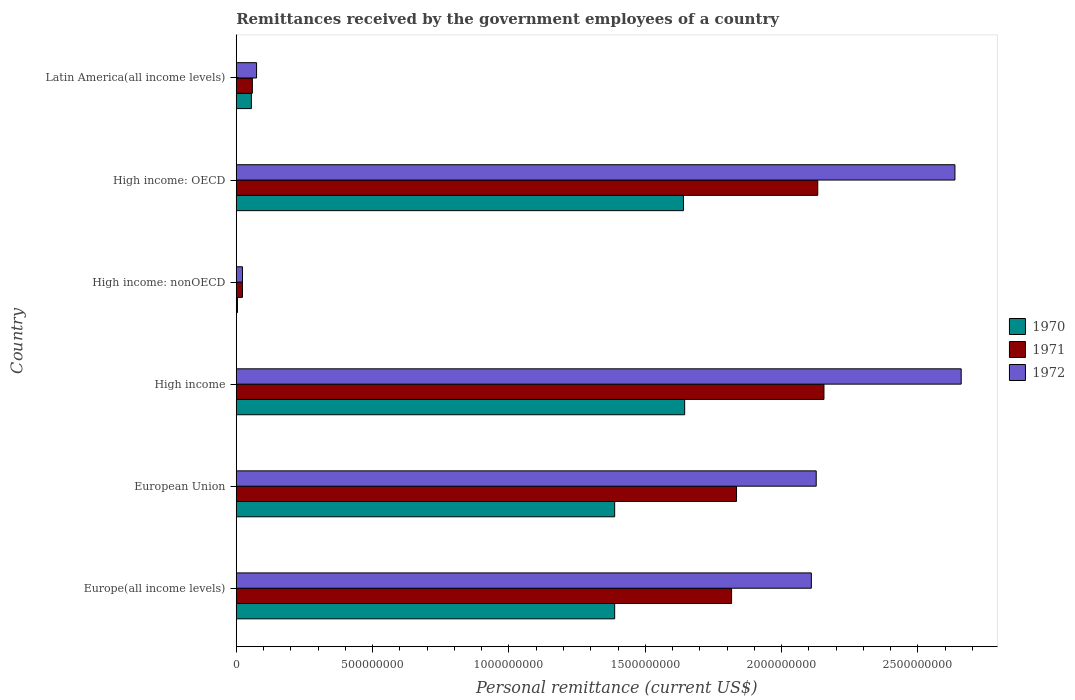How many different coloured bars are there?
Give a very brief answer. 3. Are the number of bars per tick equal to the number of legend labels?
Make the answer very short. Yes. Are the number of bars on each tick of the Y-axis equal?
Offer a very short reply. Yes. How many bars are there on the 5th tick from the top?
Ensure brevity in your answer.  3. What is the label of the 3rd group of bars from the top?
Offer a very short reply. High income: nonOECD. In how many cases, is the number of bars for a given country not equal to the number of legend labels?
Keep it short and to the point. 0. What is the remittances received by the government employees in 1970 in Europe(all income levels)?
Your response must be concise. 1.39e+09. Across all countries, what is the maximum remittances received by the government employees in 1972?
Your answer should be very brief. 2.66e+09. Across all countries, what is the minimum remittances received by the government employees in 1970?
Your answer should be compact. 4.40e+06. In which country was the remittances received by the government employees in 1970 maximum?
Your response must be concise. High income. In which country was the remittances received by the government employees in 1971 minimum?
Offer a very short reply. High income: nonOECD. What is the total remittances received by the government employees in 1970 in the graph?
Keep it short and to the point. 6.12e+09. What is the difference between the remittances received by the government employees in 1971 in European Union and that in High income: OECD?
Make the answer very short. -2.98e+08. What is the difference between the remittances received by the government employees in 1971 in High income and the remittances received by the government employees in 1972 in Latin America(all income levels)?
Ensure brevity in your answer.  2.08e+09. What is the average remittances received by the government employees in 1970 per country?
Ensure brevity in your answer.  1.02e+09. What is the difference between the remittances received by the government employees in 1971 and remittances received by the government employees in 1970 in Europe(all income levels)?
Your answer should be very brief. 4.29e+08. What is the ratio of the remittances received by the government employees in 1970 in Europe(all income levels) to that in High income: nonOECD?
Make the answer very short. 315.41. Is the remittances received by the government employees in 1972 in High income less than that in Latin America(all income levels)?
Offer a very short reply. No. What is the difference between the highest and the second highest remittances received by the government employees in 1972?
Provide a succinct answer. 2.29e+07. What is the difference between the highest and the lowest remittances received by the government employees in 1970?
Your response must be concise. 1.64e+09. What does the 3rd bar from the top in Latin America(all income levels) represents?
Provide a succinct answer. 1970. What is the difference between two consecutive major ticks on the X-axis?
Provide a short and direct response. 5.00e+08. Are the values on the major ticks of X-axis written in scientific E-notation?
Your answer should be very brief. No. Does the graph contain grids?
Provide a succinct answer. No. How are the legend labels stacked?
Ensure brevity in your answer.  Vertical. What is the title of the graph?
Offer a terse response. Remittances received by the government employees of a country. What is the label or title of the X-axis?
Give a very brief answer. Personal remittance (current US$). What is the label or title of the Y-axis?
Make the answer very short. Country. What is the Personal remittance (current US$) of 1970 in Europe(all income levels)?
Provide a succinct answer. 1.39e+09. What is the Personal remittance (current US$) of 1971 in Europe(all income levels)?
Your answer should be very brief. 1.82e+09. What is the Personal remittance (current US$) of 1972 in Europe(all income levels)?
Offer a terse response. 2.11e+09. What is the Personal remittance (current US$) of 1970 in European Union?
Offer a terse response. 1.39e+09. What is the Personal remittance (current US$) in 1971 in European Union?
Give a very brief answer. 1.83e+09. What is the Personal remittance (current US$) of 1972 in European Union?
Offer a terse response. 2.13e+09. What is the Personal remittance (current US$) in 1970 in High income?
Give a very brief answer. 1.64e+09. What is the Personal remittance (current US$) in 1971 in High income?
Your answer should be very brief. 2.16e+09. What is the Personal remittance (current US$) in 1972 in High income?
Ensure brevity in your answer.  2.66e+09. What is the Personal remittance (current US$) of 1970 in High income: nonOECD?
Your answer should be compact. 4.40e+06. What is the Personal remittance (current US$) in 1971 in High income: nonOECD?
Your response must be concise. 2.28e+07. What is the Personal remittance (current US$) of 1972 in High income: nonOECD?
Your answer should be very brief. 2.29e+07. What is the Personal remittance (current US$) of 1970 in High income: OECD?
Offer a very short reply. 1.64e+09. What is the Personal remittance (current US$) in 1971 in High income: OECD?
Your answer should be compact. 2.13e+09. What is the Personal remittance (current US$) in 1972 in High income: OECD?
Your answer should be very brief. 2.64e+09. What is the Personal remittance (current US$) in 1970 in Latin America(all income levels)?
Offer a terse response. 5.55e+07. What is the Personal remittance (current US$) in 1971 in Latin America(all income levels)?
Keep it short and to the point. 5.91e+07. What is the Personal remittance (current US$) of 1972 in Latin America(all income levels)?
Offer a very short reply. 7.45e+07. Across all countries, what is the maximum Personal remittance (current US$) in 1970?
Your response must be concise. 1.64e+09. Across all countries, what is the maximum Personal remittance (current US$) in 1971?
Provide a short and direct response. 2.16e+09. Across all countries, what is the maximum Personal remittance (current US$) of 1972?
Your answer should be compact. 2.66e+09. Across all countries, what is the minimum Personal remittance (current US$) in 1970?
Make the answer very short. 4.40e+06. Across all countries, what is the minimum Personal remittance (current US$) in 1971?
Keep it short and to the point. 2.28e+07. Across all countries, what is the minimum Personal remittance (current US$) in 1972?
Make the answer very short. 2.29e+07. What is the total Personal remittance (current US$) of 1970 in the graph?
Your response must be concise. 6.12e+09. What is the total Personal remittance (current US$) of 1971 in the graph?
Offer a terse response. 8.02e+09. What is the total Personal remittance (current US$) of 1972 in the graph?
Give a very brief answer. 9.63e+09. What is the difference between the Personal remittance (current US$) of 1971 in Europe(all income levels) and that in European Union?
Your answer should be very brief. -1.82e+07. What is the difference between the Personal remittance (current US$) in 1972 in Europe(all income levels) and that in European Union?
Offer a very short reply. -1.78e+07. What is the difference between the Personal remittance (current US$) in 1970 in Europe(all income levels) and that in High income?
Offer a very short reply. -2.57e+08. What is the difference between the Personal remittance (current US$) of 1971 in Europe(all income levels) and that in High income?
Provide a succinct answer. -3.39e+08. What is the difference between the Personal remittance (current US$) in 1972 in Europe(all income levels) and that in High income?
Keep it short and to the point. -5.49e+08. What is the difference between the Personal remittance (current US$) in 1970 in Europe(all income levels) and that in High income: nonOECD?
Offer a very short reply. 1.38e+09. What is the difference between the Personal remittance (current US$) of 1971 in Europe(all income levels) and that in High income: nonOECD?
Offer a very short reply. 1.79e+09. What is the difference between the Personal remittance (current US$) in 1972 in Europe(all income levels) and that in High income: nonOECD?
Make the answer very short. 2.09e+09. What is the difference between the Personal remittance (current US$) in 1970 in Europe(all income levels) and that in High income: OECD?
Your answer should be very brief. -2.52e+08. What is the difference between the Personal remittance (current US$) of 1971 in Europe(all income levels) and that in High income: OECD?
Make the answer very short. -3.16e+08. What is the difference between the Personal remittance (current US$) of 1972 in Europe(all income levels) and that in High income: OECD?
Your answer should be compact. -5.27e+08. What is the difference between the Personal remittance (current US$) in 1970 in Europe(all income levels) and that in Latin America(all income levels)?
Ensure brevity in your answer.  1.33e+09. What is the difference between the Personal remittance (current US$) of 1971 in Europe(all income levels) and that in Latin America(all income levels)?
Offer a terse response. 1.76e+09. What is the difference between the Personal remittance (current US$) in 1972 in Europe(all income levels) and that in Latin America(all income levels)?
Your answer should be compact. 2.03e+09. What is the difference between the Personal remittance (current US$) in 1970 in European Union and that in High income?
Keep it short and to the point. -2.57e+08. What is the difference between the Personal remittance (current US$) in 1971 in European Union and that in High income?
Your answer should be very brief. -3.21e+08. What is the difference between the Personal remittance (current US$) of 1972 in European Union and that in High income?
Give a very brief answer. -5.32e+08. What is the difference between the Personal remittance (current US$) in 1970 in European Union and that in High income: nonOECD?
Offer a very short reply. 1.38e+09. What is the difference between the Personal remittance (current US$) in 1971 in European Union and that in High income: nonOECD?
Ensure brevity in your answer.  1.81e+09. What is the difference between the Personal remittance (current US$) of 1972 in European Union and that in High income: nonOECD?
Your response must be concise. 2.10e+09. What is the difference between the Personal remittance (current US$) of 1970 in European Union and that in High income: OECD?
Keep it short and to the point. -2.52e+08. What is the difference between the Personal remittance (current US$) of 1971 in European Union and that in High income: OECD?
Give a very brief answer. -2.98e+08. What is the difference between the Personal remittance (current US$) of 1972 in European Union and that in High income: OECD?
Offer a terse response. -5.09e+08. What is the difference between the Personal remittance (current US$) in 1970 in European Union and that in Latin America(all income levels)?
Make the answer very short. 1.33e+09. What is the difference between the Personal remittance (current US$) in 1971 in European Union and that in Latin America(all income levels)?
Keep it short and to the point. 1.78e+09. What is the difference between the Personal remittance (current US$) in 1972 in European Union and that in Latin America(all income levels)?
Make the answer very short. 2.05e+09. What is the difference between the Personal remittance (current US$) in 1970 in High income and that in High income: nonOECD?
Your response must be concise. 1.64e+09. What is the difference between the Personal remittance (current US$) in 1971 in High income and that in High income: nonOECD?
Provide a short and direct response. 2.13e+09. What is the difference between the Personal remittance (current US$) in 1972 in High income and that in High income: nonOECD?
Your answer should be very brief. 2.64e+09. What is the difference between the Personal remittance (current US$) in 1970 in High income and that in High income: OECD?
Provide a short and direct response. 4.40e+06. What is the difference between the Personal remittance (current US$) in 1971 in High income and that in High income: OECD?
Keep it short and to the point. 2.28e+07. What is the difference between the Personal remittance (current US$) of 1972 in High income and that in High income: OECD?
Offer a terse response. 2.29e+07. What is the difference between the Personal remittance (current US$) in 1970 in High income and that in Latin America(all income levels)?
Ensure brevity in your answer.  1.59e+09. What is the difference between the Personal remittance (current US$) of 1971 in High income and that in Latin America(all income levels)?
Ensure brevity in your answer.  2.10e+09. What is the difference between the Personal remittance (current US$) of 1972 in High income and that in Latin America(all income levels)?
Give a very brief answer. 2.58e+09. What is the difference between the Personal remittance (current US$) in 1970 in High income: nonOECD and that in High income: OECD?
Provide a succinct answer. -1.64e+09. What is the difference between the Personal remittance (current US$) in 1971 in High income: nonOECD and that in High income: OECD?
Give a very brief answer. -2.11e+09. What is the difference between the Personal remittance (current US$) in 1972 in High income: nonOECD and that in High income: OECD?
Offer a very short reply. -2.61e+09. What is the difference between the Personal remittance (current US$) of 1970 in High income: nonOECD and that in Latin America(all income levels)?
Make the answer very short. -5.11e+07. What is the difference between the Personal remittance (current US$) of 1971 in High income: nonOECD and that in Latin America(all income levels)?
Provide a short and direct response. -3.63e+07. What is the difference between the Personal remittance (current US$) of 1972 in High income: nonOECD and that in Latin America(all income levels)?
Give a very brief answer. -5.16e+07. What is the difference between the Personal remittance (current US$) of 1970 in High income: OECD and that in Latin America(all income levels)?
Ensure brevity in your answer.  1.58e+09. What is the difference between the Personal remittance (current US$) in 1971 in High income: OECD and that in Latin America(all income levels)?
Provide a succinct answer. 2.07e+09. What is the difference between the Personal remittance (current US$) of 1972 in High income: OECD and that in Latin America(all income levels)?
Keep it short and to the point. 2.56e+09. What is the difference between the Personal remittance (current US$) in 1970 in Europe(all income levels) and the Personal remittance (current US$) in 1971 in European Union?
Make the answer very short. -4.47e+08. What is the difference between the Personal remittance (current US$) of 1970 in Europe(all income levels) and the Personal remittance (current US$) of 1972 in European Union?
Ensure brevity in your answer.  -7.39e+08. What is the difference between the Personal remittance (current US$) in 1971 in Europe(all income levels) and the Personal remittance (current US$) in 1972 in European Union?
Make the answer very short. -3.10e+08. What is the difference between the Personal remittance (current US$) of 1970 in Europe(all income levels) and the Personal remittance (current US$) of 1971 in High income?
Make the answer very short. -7.68e+08. What is the difference between the Personal remittance (current US$) in 1970 in Europe(all income levels) and the Personal remittance (current US$) in 1972 in High income?
Ensure brevity in your answer.  -1.27e+09. What is the difference between the Personal remittance (current US$) in 1971 in Europe(all income levels) and the Personal remittance (current US$) in 1972 in High income?
Your answer should be very brief. -8.42e+08. What is the difference between the Personal remittance (current US$) of 1970 in Europe(all income levels) and the Personal remittance (current US$) of 1971 in High income: nonOECD?
Provide a succinct answer. 1.37e+09. What is the difference between the Personal remittance (current US$) of 1970 in Europe(all income levels) and the Personal remittance (current US$) of 1972 in High income: nonOECD?
Ensure brevity in your answer.  1.36e+09. What is the difference between the Personal remittance (current US$) in 1971 in Europe(all income levels) and the Personal remittance (current US$) in 1972 in High income: nonOECD?
Your answer should be very brief. 1.79e+09. What is the difference between the Personal remittance (current US$) in 1970 in Europe(all income levels) and the Personal remittance (current US$) in 1971 in High income: OECD?
Give a very brief answer. -7.45e+08. What is the difference between the Personal remittance (current US$) of 1970 in Europe(all income levels) and the Personal remittance (current US$) of 1972 in High income: OECD?
Ensure brevity in your answer.  -1.25e+09. What is the difference between the Personal remittance (current US$) of 1971 in Europe(all income levels) and the Personal remittance (current US$) of 1972 in High income: OECD?
Offer a very short reply. -8.19e+08. What is the difference between the Personal remittance (current US$) of 1970 in Europe(all income levels) and the Personal remittance (current US$) of 1971 in Latin America(all income levels)?
Ensure brevity in your answer.  1.33e+09. What is the difference between the Personal remittance (current US$) in 1970 in Europe(all income levels) and the Personal remittance (current US$) in 1972 in Latin America(all income levels)?
Your answer should be very brief. 1.31e+09. What is the difference between the Personal remittance (current US$) in 1971 in Europe(all income levels) and the Personal remittance (current US$) in 1972 in Latin America(all income levels)?
Ensure brevity in your answer.  1.74e+09. What is the difference between the Personal remittance (current US$) of 1970 in European Union and the Personal remittance (current US$) of 1971 in High income?
Give a very brief answer. -7.68e+08. What is the difference between the Personal remittance (current US$) in 1970 in European Union and the Personal remittance (current US$) in 1972 in High income?
Make the answer very short. -1.27e+09. What is the difference between the Personal remittance (current US$) of 1971 in European Union and the Personal remittance (current US$) of 1972 in High income?
Your answer should be compact. -8.24e+08. What is the difference between the Personal remittance (current US$) of 1970 in European Union and the Personal remittance (current US$) of 1971 in High income: nonOECD?
Provide a short and direct response. 1.37e+09. What is the difference between the Personal remittance (current US$) in 1970 in European Union and the Personal remittance (current US$) in 1972 in High income: nonOECD?
Give a very brief answer. 1.36e+09. What is the difference between the Personal remittance (current US$) of 1971 in European Union and the Personal remittance (current US$) of 1972 in High income: nonOECD?
Your answer should be compact. 1.81e+09. What is the difference between the Personal remittance (current US$) of 1970 in European Union and the Personal remittance (current US$) of 1971 in High income: OECD?
Provide a short and direct response. -7.45e+08. What is the difference between the Personal remittance (current US$) of 1970 in European Union and the Personal remittance (current US$) of 1972 in High income: OECD?
Keep it short and to the point. -1.25e+09. What is the difference between the Personal remittance (current US$) in 1971 in European Union and the Personal remittance (current US$) in 1972 in High income: OECD?
Your answer should be very brief. -8.01e+08. What is the difference between the Personal remittance (current US$) in 1970 in European Union and the Personal remittance (current US$) in 1971 in Latin America(all income levels)?
Keep it short and to the point. 1.33e+09. What is the difference between the Personal remittance (current US$) in 1970 in European Union and the Personal remittance (current US$) in 1972 in Latin America(all income levels)?
Give a very brief answer. 1.31e+09. What is the difference between the Personal remittance (current US$) in 1971 in European Union and the Personal remittance (current US$) in 1972 in Latin America(all income levels)?
Provide a short and direct response. 1.76e+09. What is the difference between the Personal remittance (current US$) in 1970 in High income and the Personal remittance (current US$) in 1971 in High income: nonOECD?
Offer a terse response. 1.62e+09. What is the difference between the Personal remittance (current US$) of 1970 in High income and the Personal remittance (current US$) of 1972 in High income: nonOECD?
Your response must be concise. 1.62e+09. What is the difference between the Personal remittance (current US$) in 1971 in High income and the Personal remittance (current US$) in 1972 in High income: nonOECD?
Ensure brevity in your answer.  2.13e+09. What is the difference between the Personal remittance (current US$) of 1970 in High income and the Personal remittance (current US$) of 1971 in High income: OECD?
Make the answer very short. -4.88e+08. What is the difference between the Personal remittance (current US$) in 1970 in High income and the Personal remittance (current US$) in 1972 in High income: OECD?
Offer a terse response. -9.91e+08. What is the difference between the Personal remittance (current US$) of 1971 in High income and the Personal remittance (current US$) of 1972 in High income: OECD?
Your response must be concise. -4.80e+08. What is the difference between the Personal remittance (current US$) of 1970 in High income and the Personal remittance (current US$) of 1971 in Latin America(all income levels)?
Provide a short and direct response. 1.59e+09. What is the difference between the Personal remittance (current US$) in 1970 in High income and the Personal remittance (current US$) in 1972 in Latin America(all income levels)?
Ensure brevity in your answer.  1.57e+09. What is the difference between the Personal remittance (current US$) in 1971 in High income and the Personal remittance (current US$) in 1972 in Latin America(all income levels)?
Provide a succinct answer. 2.08e+09. What is the difference between the Personal remittance (current US$) of 1970 in High income: nonOECD and the Personal remittance (current US$) of 1971 in High income: OECD?
Keep it short and to the point. -2.13e+09. What is the difference between the Personal remittance (current US$) in 1970 in High income: nonOECD and the Personal remittance (current US$) in 1972 in High income: OECD?
Your response must be concise. -2.63e+09. What is the difference between the Personal remittance (current US$) of 1971 in High income: nonOECD and the Personal remittance (current US$) of 1972 in High income: OECD?
Your answer should be compact. -2.61e+09. What is the difference between the Personal remittance (current US$) in 1970 in High income: nonOECD and the Personal remittance (current US$) in 1971 in Latin America(all income levels)?
Your response must be concise. -5.47e+07. What is the difference between the Personal remittance (current US$) of 1970 in High income: nonOECD and the Personal remittance (current US$) of 1972 in Latin America(all income levels)?
Provide a succinct answer. -7.01e+07. What is the difference between the Personal remittance (current US$) in 1971 in High income: nonOECD and the Personal remittance (current US$) in 1972 in Latin America(all income levels)?
Provide a succinct answer. -5.17e+07. What is the difference between the Personal remittance (current US$) of 1970 in High income: OECD and the Personal remittance (current US$) of 1971 in Latin America(all income levels)?
Your answer should be very brief. 1.58e+09. What is the difference between the Personal remittance (current US$) in 1970 in High income: OECD and the Personal remittance (current US$) in 1972 in Latin America(all income levels)?
Provide a short and direct response. 1.57e+09. What is the difference between the Personal remittance (current US$) in 1971 in High income: OECD and the Personal remittance (current US$) in 1972 in Latin America(all income levels)?
Ensure brevity in your answer.  2.06e+09. What is the average Personal remittance (current US$) in 1970 per country?
Provide a short and direct response. 1.02e+09. What is the average Personal remittance (current US$) of 1971 per country?
Offer a very short reply. 1.34e+09. What is the average Personal remittance (current US$) in 1972 per country?
Make the answer very short. 1.60e+09. What is the difference between the Personal remittance (current US$) of 1970 and Personal remittance (current US$) of 1971 in Europe(all income levels)?
Your answer should be very brief. -4.29e+08. What is the difference between the Personal remittance (current US$) of 1970 and Personal remittance (current US$) of 1972 in Europe(all income levels)?
Provide a short and direct response. -7.21e+08. What is the difference between the Personal remittance (current US$) in 1971 and Personal remittance (current US$) in 1972 in Europe(all income levels)?
Provide a succinct answer. -2.93e+08. What is the difference between the Personal remittance (current US$) in 1970 and Personal remittance (current US$) in 1971 in European Union?
Offer a very short reply. -4.47e+08. What is the difference between the Personal remittance (current US$) of 1970 and Personal remittance (current US$) of 1972 in European Union?
Provide a succinct answer. -7.39e+08. What is the difference between the Personal remittance (current US$) of 1971 and Personal remittance (current US$) of 1972 in European Union?
Your answer should be very brief. -2.92e+08. What is the difference between the Personal remittance (current US$) of 1970 and Personal remittance (current US$) of 1971 in High income?
Ensure brevity in your answer.  -5.11e+08. What is the difference between the Personal remittance (current US$) in 1970 and Personal remittance (current US$) in 1972 in High income?
Ensure brevity in your answer.  -1.01e+09. What is the difference between the Personal remittance (current US$) of 1971 and Personal remittance (current US$) of 1972 in High income?
Your answer should be compact. -5.03e+08. What is the difference between the Personal remittance (current US$) in 1970 and Personal remittance (current US$) in 1971 in High income: nonOECD?
Keep it short and to the point. -1.84e+07. What is the difference between the Personal remittance (current US$) of 1970 and Personal remittance (current US$) of 1972 in High income: nonOECD?
Your answer should be compact. -1.85e+07. What is the difference between the Personal remittance (current US$) in 1971 and Personal remittance (current US$) in 1972 in High income: nonOECD?
Keep it short and to the point. -1.37e+05. What is the difference between the Personal remittance (current US$) of 1970 and Personal remittance (current US$) of 1971 in High income: OECD?
Make the answer very short. -4.92e+08. What is the difference between the Personal remittance (current US$) in 1970 and Personal remittance (current US$) in 1972 in High income: OECD?
Make the answer very short. -9.96e+08. What is the difference between the Personal remittance (current US$) of 1971 and Personal remittance (current US$) of 1972 in High income: OECD?
Provide a succinct answer. -5.03e+08. What is the difference between the Personal remittance (current US$) of 1970 and Personal remittance (current US$) of 1971 in Latin America(all income levels)?
Make the answer very short. -3.57e+06. What is the difference between the Personal remittance (current US$) of 1970 and Personal remittance (current US$) of 1972 in Latin America(all income levels)?
Give a very brief answer. -1.90e+07. What is the difference between the Personal remittance (current US$) in 1971 and Personal remittance (current US$) in 1972 in Latin America(all income levels)?
Offer a terse response. -1.54e+07. What is the ratio of the Personal remittance (current US$) in 1972 in Europe(all income levels) to that in European Union?
Make the answer very short. 0.99. What is the ratio of the Personal remittance (current US$) of 1970 in Europe(all income levels) to that in High income?
Ensure brevity in your answer.  0.84. What is the ratio of the Personal remittance (current US$) of 1971 in Europe(all income levels) to that in High income?
Provide a succinct answer. 0.84. What is the ratio of the Personal remittance (current US$) of 1972 in Europe(all income levels) to that in High income?
Keep it short and to the point. 0.79. What is the ratio of the Personal remittance (current US$) of 1970 in Europe(all income levels) to that in High income: nonOECD?
Your answer should be compact. 315.41. What is the ratio of the Personal remittance (current US$) in 1971 in Europe(all income levels) to that in High income: nonOECD?
Your answer should be compact. 79.73. What is the ratio of the Personal remittance (current US$) in 1972 in Europe(all income levels) to that in High income: nonOECD?
Give a very brief answer. 92.02. What is the ratio of the Personal remittance (current US$) in 1970 in Europe(all income levels) to that in High income: OECD?
Offer a very short reply. 0.85. What is the ratio of the Personal remittance (current US$) of 1971 in Europe(all income levels) to that in High income: OECD?
Ensure brevity in your answer.  0.85. What is the ratio of the Personal remittance (current US$) of 1972 in Europe(all income levels) to that in High income: OECD?
Your answer should be very brief. 0.8. What is the ratio of the Personal remittance (current US$) of 1970 in Europe(all income levels) to that in Latin America(all income levels)?
Give a very brief answer. 25.01. What is the ratio of the Personal remittance (current US$) in 1971 in Europe(all income levels) to that in Latin America(all income levels)?
Offer a terse response. 30.75. What is the ratio of the Personal remittance (current US$) in 1972 in Europe(all income levels) to that in Latin America(all income levels)?
Your response must be concise. 28.32. What is the ratio of the Personal remittance (current US$) in 1970 in European Union to that in High income?
Provide a succinct answer. 0.84. What is the ratio of the Personal remittance (current US$) of 1971 in European Union to that in High income?
Your response must be concise. 0.85. What is the ratio of the Personal remittance (current US$) in 1970 in European Union to that in High income: nonOECD?
Keep it short and to the point. 315.41. What is the ratio of the Personal remittance (current US$) in 1971 in European Union to that in High income: nonOECD?
Make the answer very short. 80.52. What is the ratio of the Personal remittance (current US$) of 1972 in European Union to that in High income: nonOECD?
Provide a short and direct response. 92.79. What is the ratio of the Personal remittance (current US$) of 1970 in European Union to that in High income: OECD?
Offer a very short reply. 0.85. What is the ratio of the Personal remittance (current US$) of 1971 in European Union to that in High income: OECD?
Your response must be concise. 0.86. What is the ratio of the Personal remittance (current US$) in 1972 in European Union to that in High income: OECD?
Ensure brevity in your answer.  0.81. What is the ratio of the Personal remittance (current US$) in 1970 in European Union to that in Latin America(all income levels)?
Your answer should be very brief. 25.01. What is the ratio of the Personal remittance (current US$) in 1971 in European Union to that in Latin America(all income levels)?
Provide a short and direct response. 31.06. What is the ratio of the Personal remittance (current US$) in 1972 in European Union to that in Latin America(all income levels)?
Make the answer very short. 28.56. What is the ratio of the Personal remittance (current US$) in 1970 in High income to that in High income: nonOECD?
Provide a succinct answer. 373.75. What is the ratio of the Personal remittance (current US$) in 1971 in High income to that in High income: nonOECD?
Offer a terse response. 94.6. What is the ratio of the Personal remittance (current US$) in 1972 in High income to that in High income: nonOECD?
Give a very brief answer. 115.99. What is the ratio of the Personal remittance (current US$) of 1970 in High income to that in High income: OECD?
Offer a very short reply. 1. What is the ratio of the Personal remittance (current US$) in 1971 in High income to that in High income: OECD?
Provide a succinct answer. 1.01. What is the ratio of the Personal remittance (current US$) in 1972 in High income to that in High income: OECD?
Offer a terse response. 1.01. What is the ratio of the Personal remittance (current US$) in 1970 in High income to that in Latin America(all income levels)?
Offer a very short reply. 29.63. What is the ratio of the Personal remittance (current US$) in 1971 in High income to that in Latin America(all income levels)?
Offer a very short reply. 36.49. What is the ratio of the Personal remittance (current US$) in 1972 in High income to that in Latin America(all income levels)?
Provide a succinct answer. 35.7. What is the ratio of the Personal remittance (current US$) of 1970 in High income: nonOECD to that in High income: OECD?
Give a very brief answer. 0. What is the ratio of the Personal remittance (current US$) of 1971 in High income: nonOECD to that in High income: OECD?
Offer a very short reply. 0.01. What is the ratio of the Personal remittance (current US$) of 1972 in High income: nonOECD to that in High income: OECD?
Give a very brief answer. 0.01. What is the ratio of the Personal remittance (current US$) of 1970 in High income: nonOECD to that in Latin America(all income levels)?
Offer a terse response. 0.08. What is the ratio of the Personal remittance (current US$) in 1971 in High income: nonOECD to that in Latin America(all income levels)?
Provide a short and direct response. 0.39. What is the ratio of the Personal remittance (current US$) in 1972 in High income: nonOECD to that in Latin America(all income levels)?
Offer a terse response. 0.31. What is the ratio of the Personal remittance (current US$) of 1970 in High income: OECD to that in Latin America(all income levels)?
Your answer should be very brief. 29.55. What is the ratio of the Personal remittance (current US$) of 1971 in High income: OECD to that in Latin America(all income levels)?
Offer a terse response. 36.1. What is the ratio of the Personal remittance (current US$) of 1972 in High income: OECD to that in Latin America(all income levels)?
Ensure brevity in your answer.  35.39. What is the difference between the highest and the second highest Personal remittance (current US$) in 1970?
Your answer should be compact. 4.40e+06. What is the difference between the highest and the second highest Personal remittance (current US$) of 1971?
Your response must be concise. 2.28e+07. What is the difference between the highest and the second highest Personal remittance (current US$) in 1972?
Provide a short and direct response. 2.29e+07. What is the difference between the highest and the lowest Personal remittance (current US$) in 1970?
Make the answer very short. 1.64e+09. What is the difference between the highest and the lowest Personal remittance (current US$) of 1971?
Offer a terse response. 2.13e+09. What is the difference between the highest and the lowest Personal remittance (current US$) of 1972?
Provide a succinct answer. 2.64e+09. 